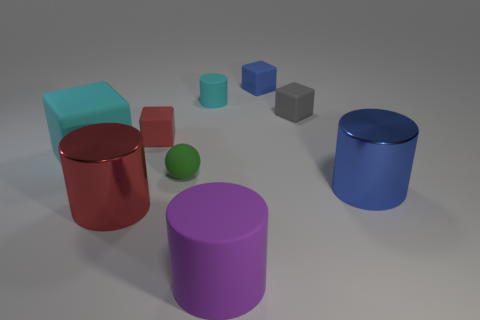Is the shape of the gray matte thing the same as the big shiny thing to the right of the red block?
Provide a short and direct response. No. There is a thing that is both in front of the green matte sphere and on the left side of the small rubber cylinder; what is its size?
Offer a terse response. Large. Is there a small blue ball that has the same material as the tiny gray cube?
Your answer should be compact. No. What is the size of the matte cylinder that is the same color as the large rubber block?
Ensure brevity in your answer.  Small. What is the small cube that is on the left side of the matte cylinder that is in front of the small gray block made of?
Your answer should be compact. Rubber. How many other balls are the same color as the tiny ball?
Give a very brief answer. 0. What is the size of the blue cube that is made of the same material as the tiny ball?
Provide a short and direct response. Small. There is a cyan rubber object that is right of the big red thing; what shape is it?
Your response must be concise. Cylinder. There is a purple object that is the same shape as the big red object; what size is it?
Ensure brevity in your answer.  Large. There is a gray cube that is in front of the blue thing behind the matte ball; what number of small spheres are behind it?
Make the answer very short. 0. 